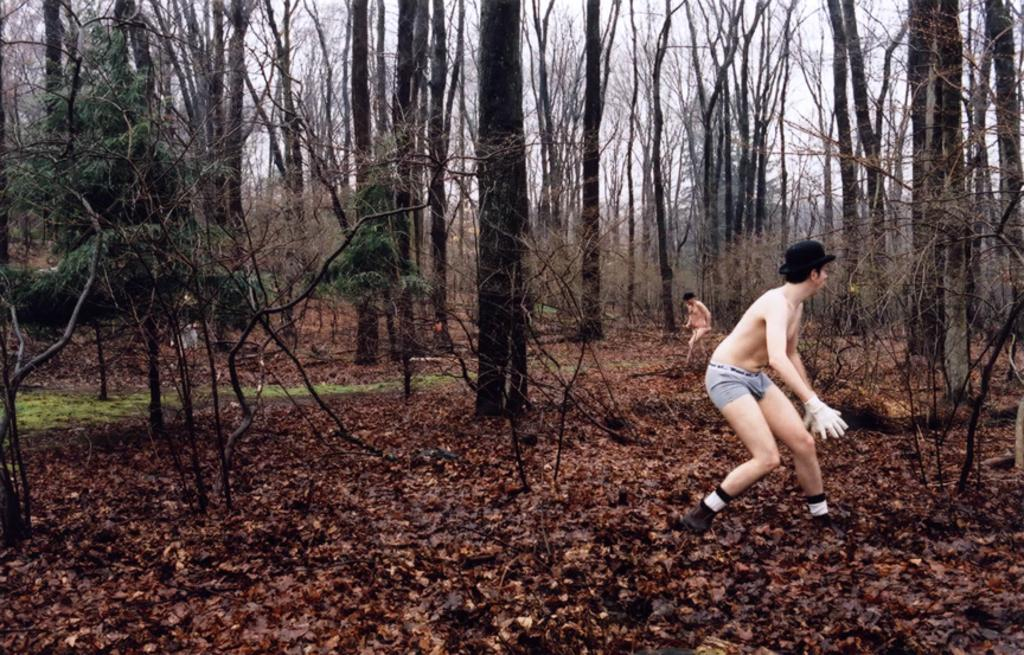How many people are present in the image? There are two persons standing in the image. What is the surface on which the persons are standing? The persons are standing on the ground. What can be seen in the background of the image? There are trees and the sky visible in the background of the image. What type of brass instrument is being taught by one of the persons in the image? There is no brass instrument or teaching activity present in the image. How many cows are grazing in the background of the image? There are no cows visible in the image; only trees and the sky can be seen in the background. 